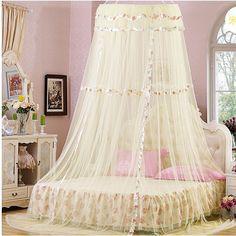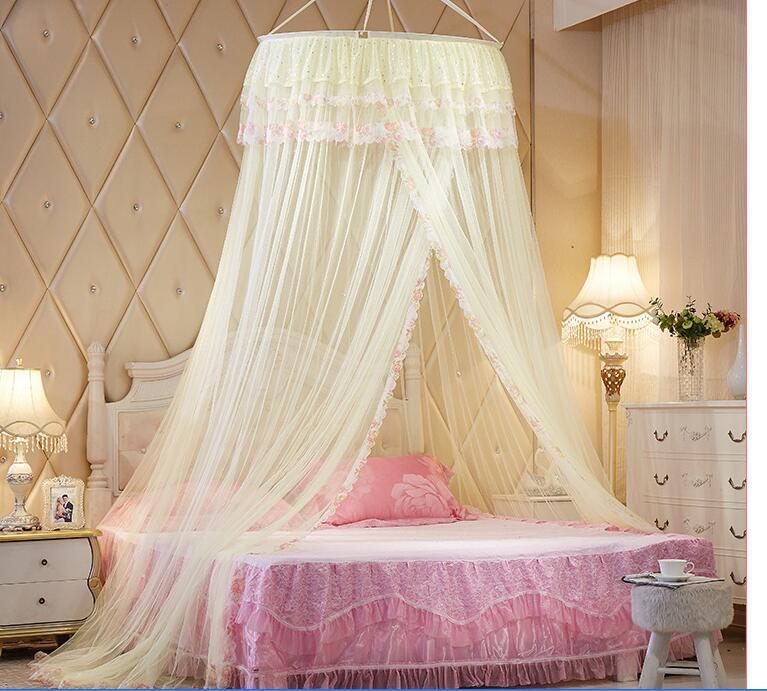The first image is the image on the left, the second image is the image on the right. Given the left and right images, does the statement "The left and right image contains the same number of canopies one square and one circle." hold true? Answer yes or no. No. 